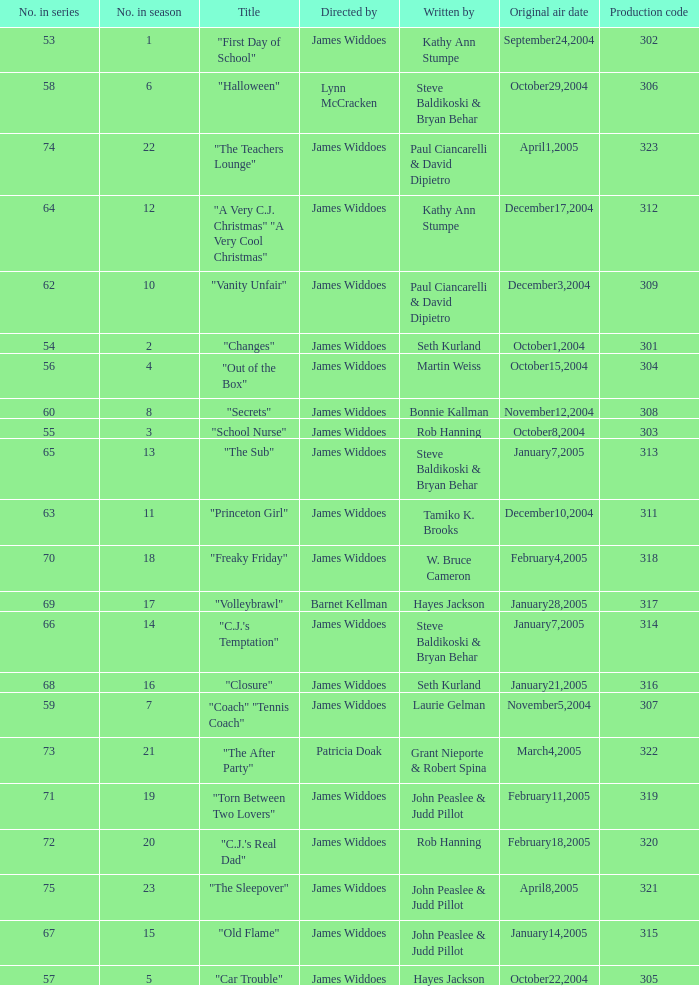Who directed "Freaky Friday"? James Widdoes. 